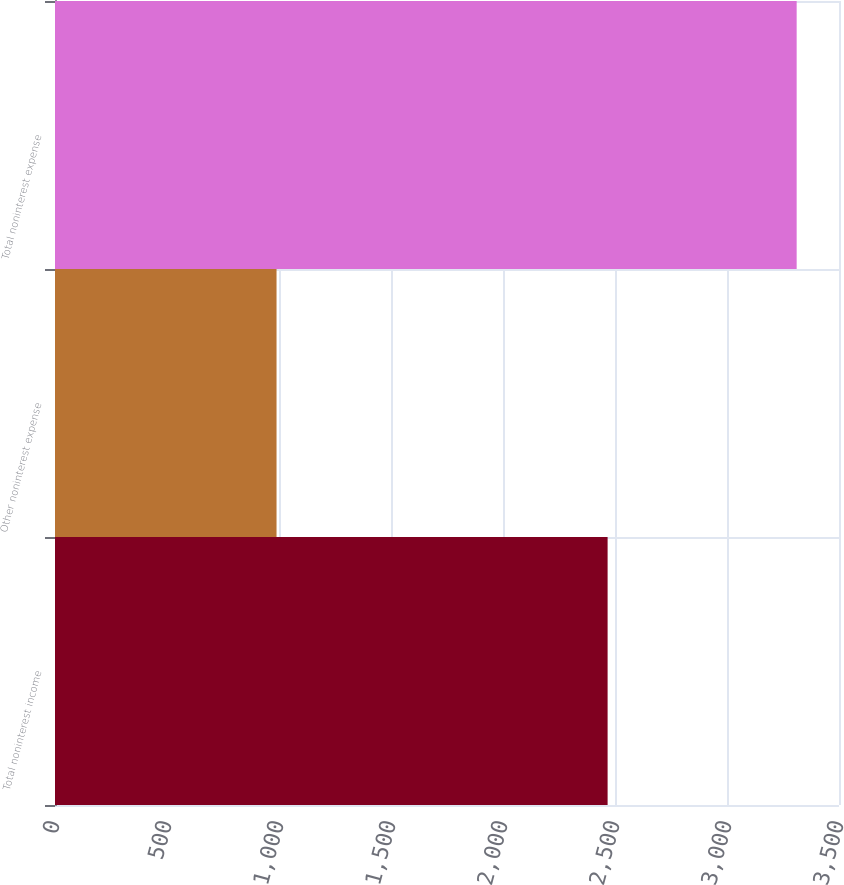Convert chart to OTSL. <chart><loc_0><loc_0><loc_500><loc_500><bar_chart><fcel>Total noninterest income<fcel>Other noninterest expense<fcel>Total noninterest expense<nl><fcel>2467<fcel>989<fcel>3311<nl></chart> 